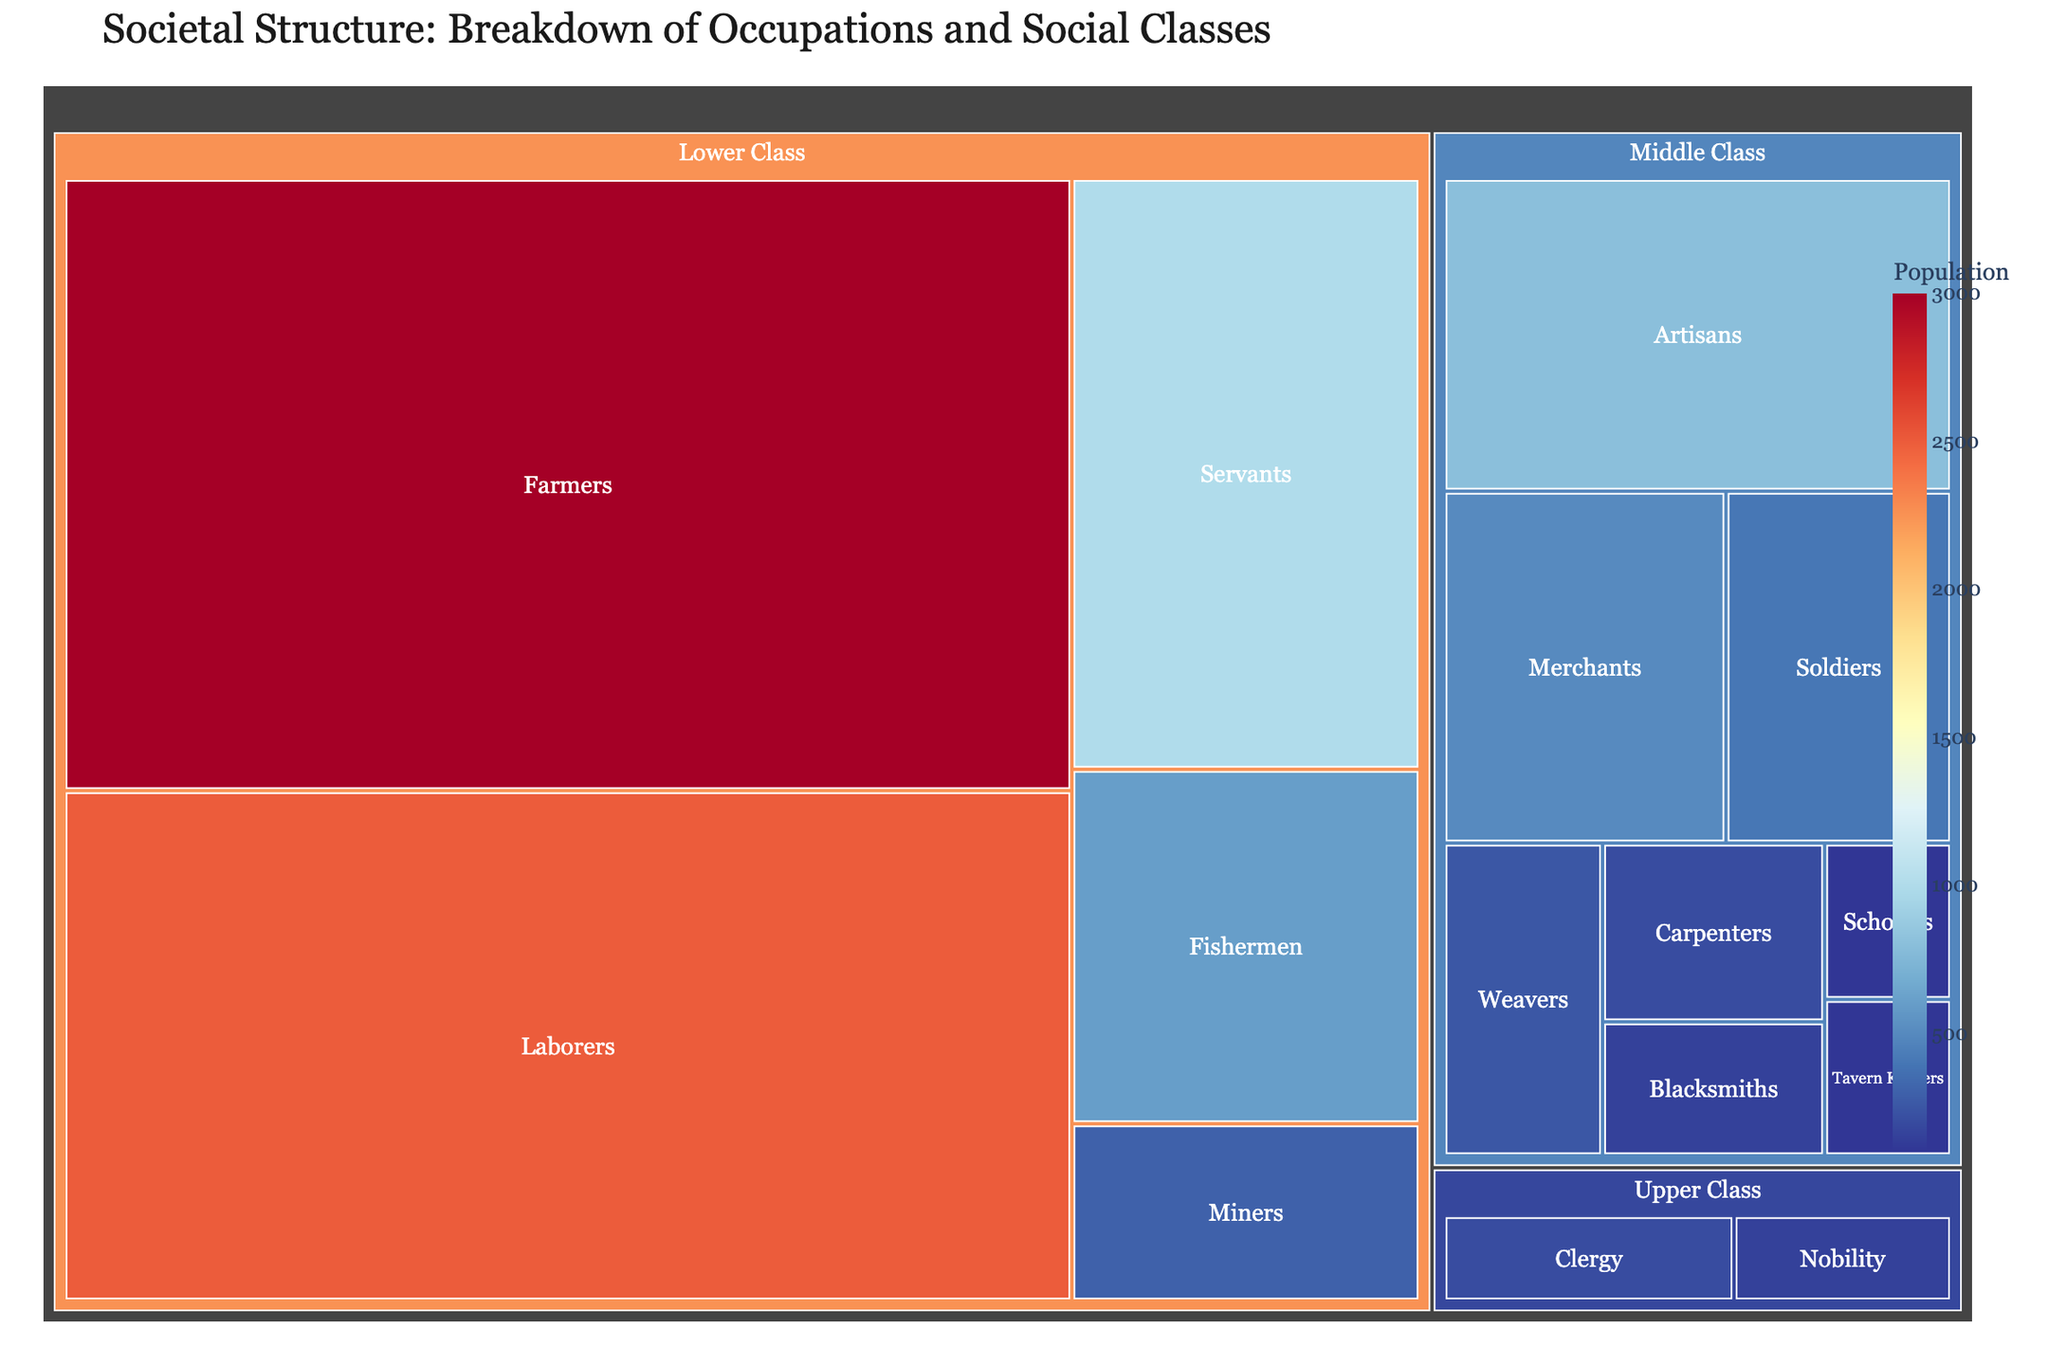What is the title of the treemap? The title of the treemap is always displayed at the top and provides an overview of the visualized information.
Answer: Societal Structure: Breakdown of Occupations and Social Classes Which occupation has the highest population within the lower class? To find this, look for the largest rectangle under the Lower Class section. As this is a treemap, larger rectangles represent higher populations.
Answer: Farmers How many different occupational groups are listed under the middle class? Count each distinct rectangle within the Middle Class section. Each rectangle represents a unique occupation.
Answer: Seven What is the total population of the middle class? Sum the populations of all occupations that fall under the Middle Class section. Add 500 (Merchants) + 800 (Artisans) + 400 (Soldiers) + 100 (Scholars) + 150 (Blacksmiths) + 200 (Carpenters) + 250 (Weavers) + 100 (Tavern Keepers).
Answer: 2500 Which class has the smallest population overall? Compare the total population for the Upper Class, Middle Class, and Lower Class segments. The one with the smallest total is the answer.
Answer: Upper Class How does the population of the clergy compare to that of the nobility? Look at the population numbers for Clergy and Nobility within the Upper Class section and compare them. Clergy has 200 and Nobility has 150.
Answer: Clergy has a higher population than Nobility What is the combined population of soldiers, tavern keepers, and weavers? Add the population numbers for Soldiers (400), Tavern Keepers (100), and Weavers (250). 400 + 100 + 250 = 750.
Answer: 750 Which occupation has the lowest population in the middle class? Identify the smallest rectangle in the Middle Class section, as the smallest size indicates the lowest population.
Answer: Scholars What is the difference in population between laborers and servants? Subtract the population of servants (1000) from the population of laborers (2500). 2500 - 1000 = 1500.
Answer: 1500 Is there an occupation in the lower class with a population equal to the total population of the upper class? Compare the population numbers. The total population of the Upper Class is 150 (Nobility) + 200 (Clergy) = 350. Look for any lower class occupation with exactly 350.
Answer: No 